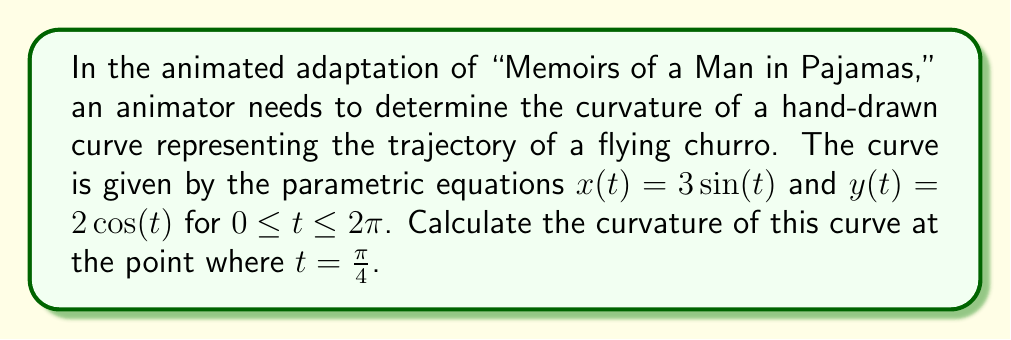Provide a solution to this math problem. To find the curvature of a parametric curve, we'll use the formula:

$$ \kappa = \frac{|x'y'' - y'x''|}{(x'^2 + y'^2)^{3/2}} $$

Step 1: Calculate the first derivatives
$x'(t) = 3\cos(t)$
$y'(t) = -2\sin(t)$

Step 2: Calculate the second derivatives
$x''(t) = -3\sin(t)$
$y''(t) = -2\cos(t)$

Step 3: Evaluate the derivatives at $t = \frac{\pi}{4}$
$x'(\frac{\pi}{4}) = 3\cos(\frac{\pi}{4}) = \frac{3\sqrt{2}}{2}$
$y'(\frac{\pi}{4}) = -2\sin(\frac{\pi}{4}) = -\sqrt{2}$
$x''(\frac{\pi}{4}) = -3\sin(\frac{\pi}{4}) = -\frac{3\sqrt{2}}{2}$
$y''(\frac{\pi}{4}) = -2\cos(\frac{\pi}{4}) = -\sqrt{2}$

Step 4: Calculate the numerator of the curvature formula
$|x'y'' - y'x''| = |\frac{3\sqrt{2}}{2}(-\sqrt{2}) - (-\sqrt{2})(-\frac{3\sqrt{2}}{2})|$
$= |-3 - 3| = 6$

Step 5: Calculate the denominator of the curvature formula
$(x'^2 + y'^2)^{3/2} = ((\frac{3\sqrt{2}}{2})^2 + (-\sqrt{2})^2)^{3/2}$
$= (\frac{9}{2} + 2)^{3/2} = (\frac{13}{2})^{3/2}$

Step 6: Compute the final curvature
$\kappa = \frac{6}{(\frac{13}{2})^{3/2}} = \frac{12}{13\sqrt{13}}$
Answer: $\frac{12}{13\sqrt{13}}$ 